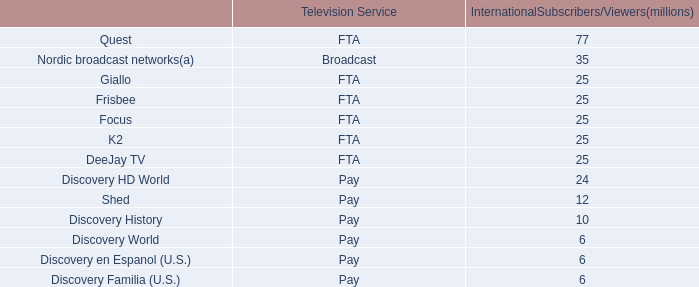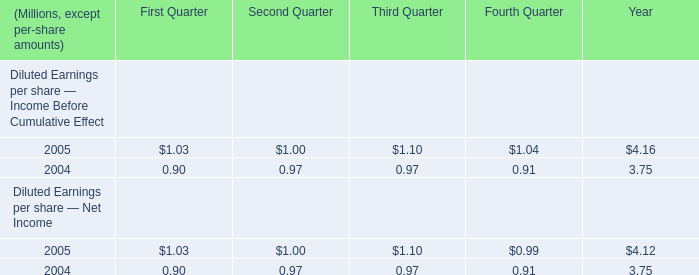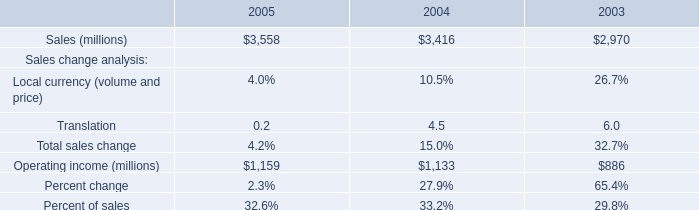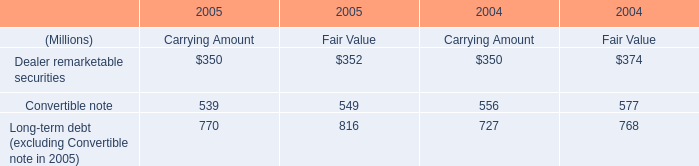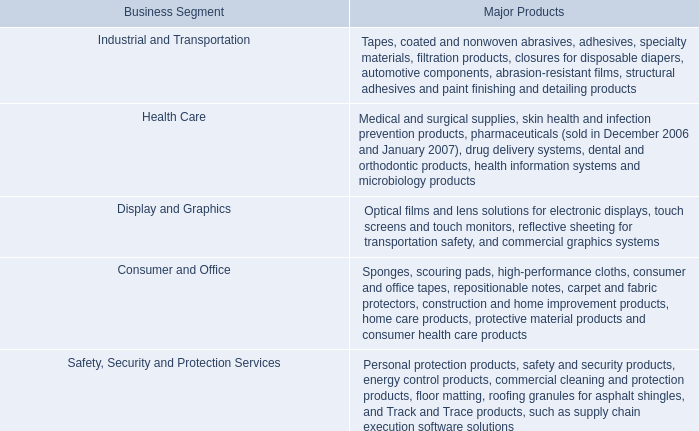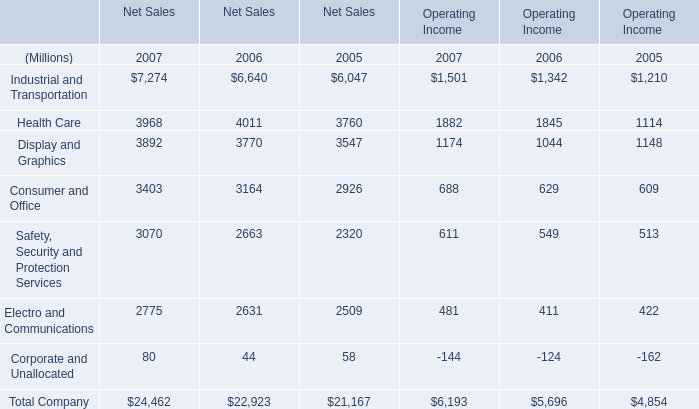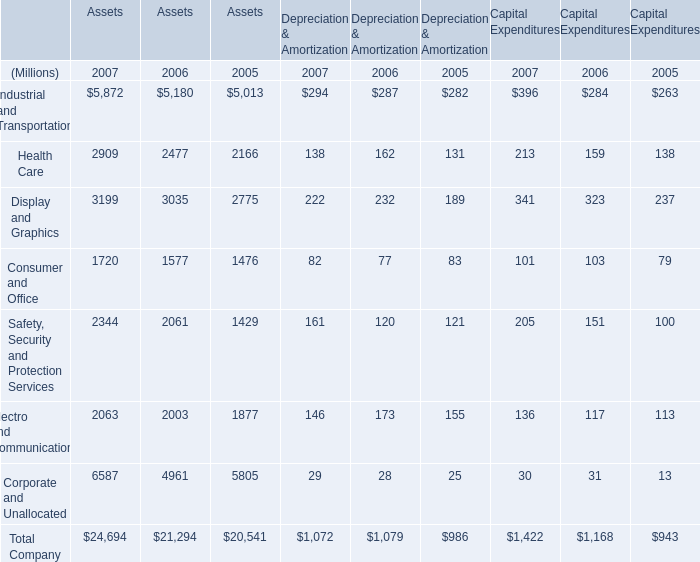In the section with the most Health Care, what is the growth rate of Display and Graphics? 
Computations: ((3770 - 3547) / 3547)
Answer: 0.06287. 